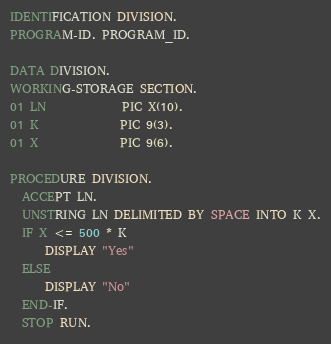Convert code to text. <code><loc_0><loc_0><loc_500><loc_500><_COBOL_>IDENTIFICATION DIVISION.
PROGRAM-ID. PROGRAM_ID.

DATA DIVISION.
WORKING-STORAGE SECTION.
01 LN             PIC X(10).
01 K              PIC 9(3).
01 X              PIC 9(6).

PROCEDURE DIVISION.
  ACCEPT LN.
  UNSTRING LN DELIMITED BY SPACE INTO K X.
  IF X <= 500 * K
      DISPLAY "Yes"
  ELSE
      DISPLAY "No"
  END-IF.
  STOP RUN.
</code> 